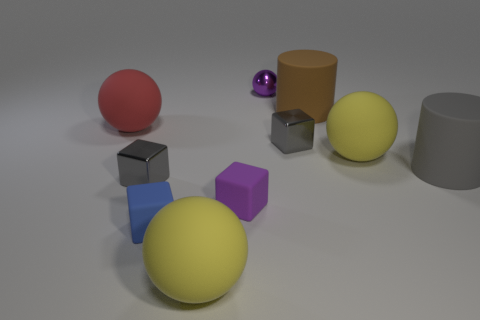Is there a small metal object?
Offer a very short reply. Yes. Is the number of matte cylinders that are left of the blue matte thing greater than the number of shiny balls that are on the right side of the purple ball?
Provide a short and direct response. No. What size is the purple thing that is the same material as the brown thing?
Make the answer very short. Small. There is a metallic block right of the gray object to the left of the big yellow rubber thing in front of the gray cylinder; what size is it?
Offer a terse response. Small. What color is the cylinder that is on the right side of the large brown object?
Your answer should be compact. Gray. Is the number of large gray cylinders in front of the blue cube greater than the number of big rubber objects?
Your response must be concise. No. There is a purple thing in front of the purple metallic object; is its shape the same as the large brown thing?
Provide a succinct answer. No. How many yellow objects are shiny balls or large matte objects?
Offer a very short reply. 2. Are there more large brown things than small shiny objects?
Provide a short and direct response. No. There is a metallic ball that is the same size as the purple matte block; what color is it?
Offer a terse response. Purple. 